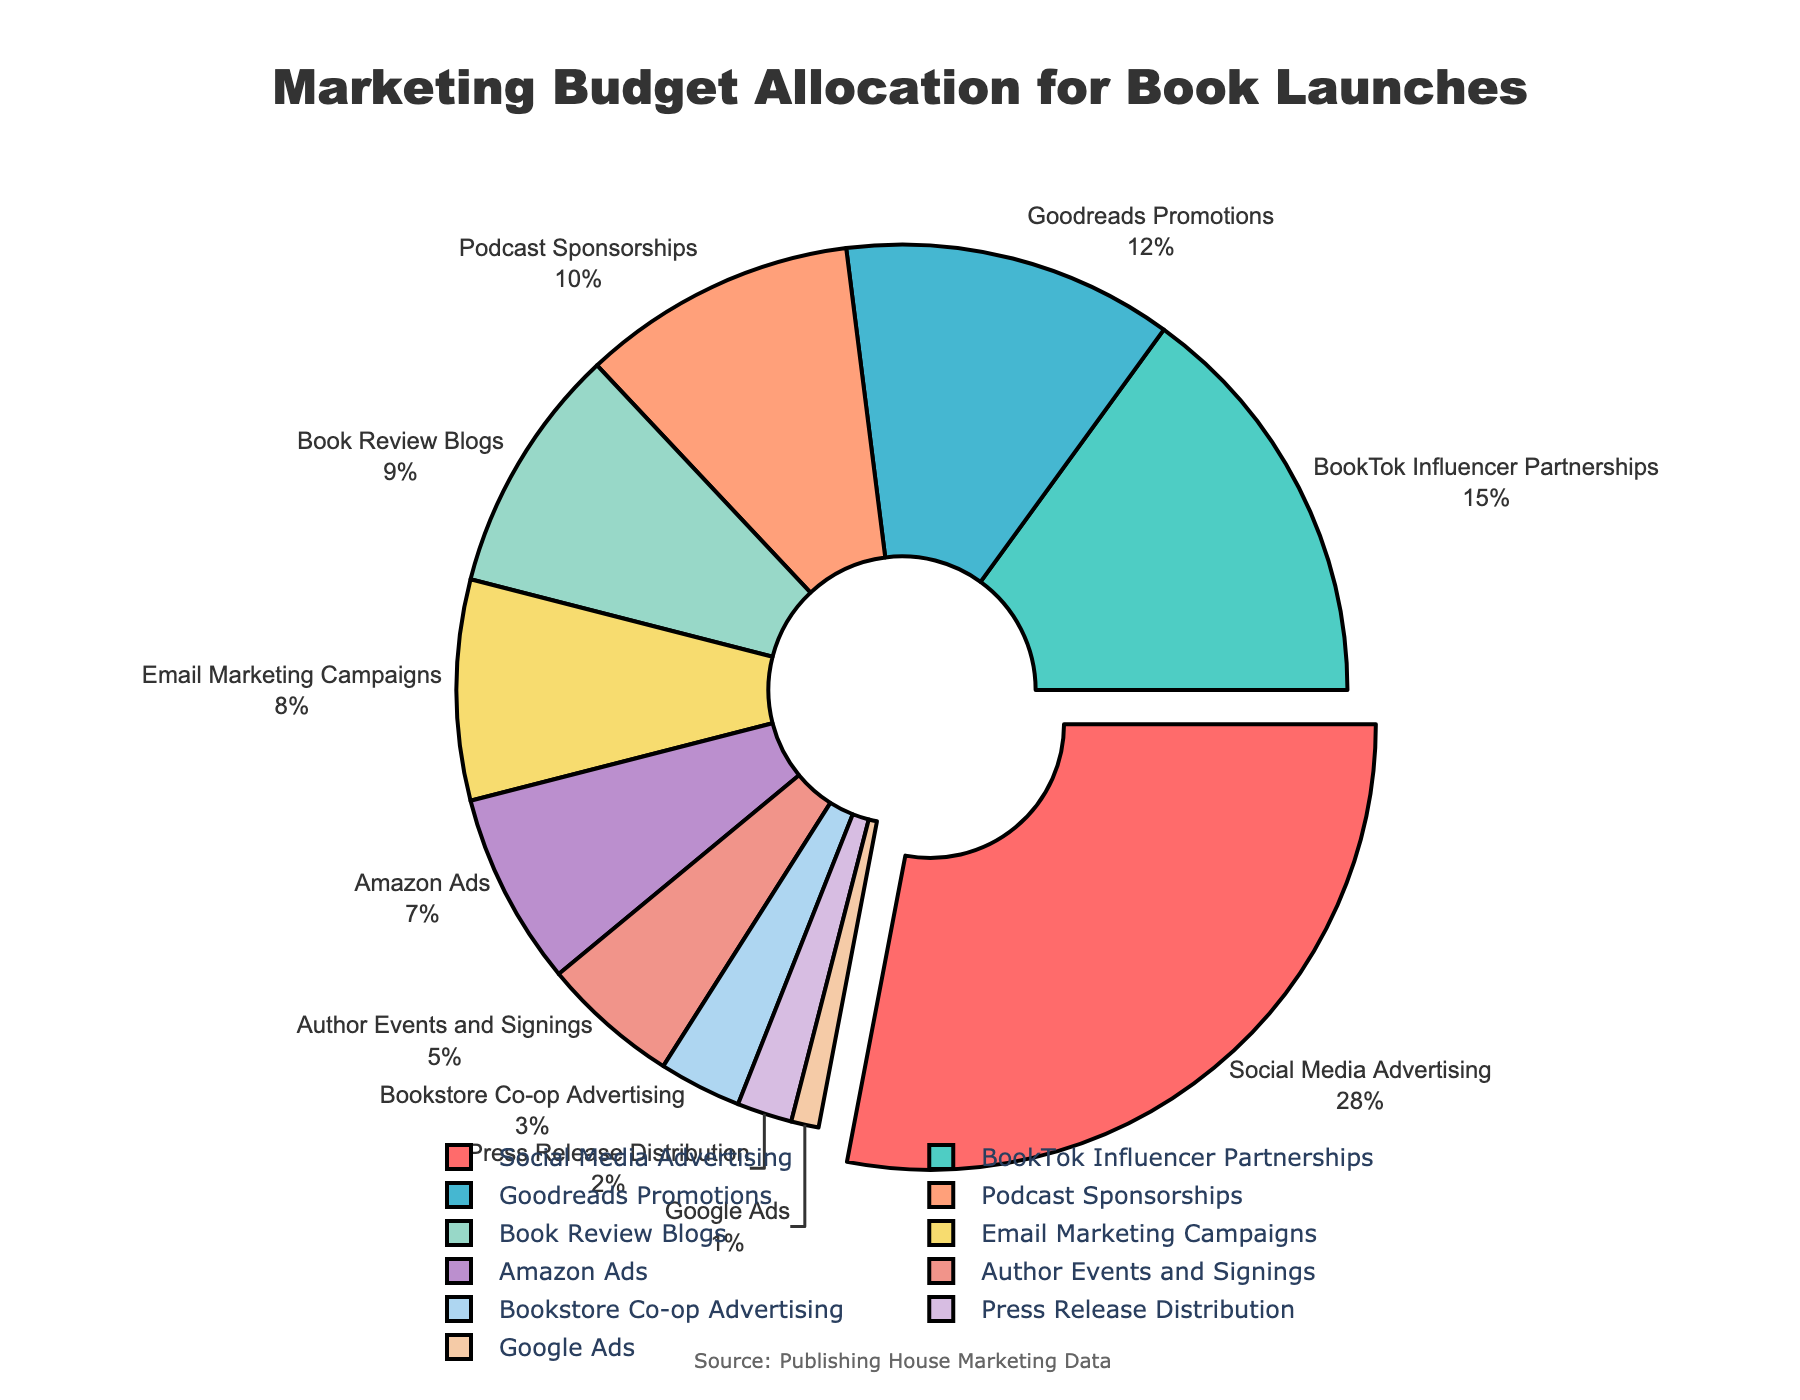What percentage of the marketing budget is allocated to Social Media Advertising? Locate the "Social Media Advertising" segment on the pie chart and read the percentage label next to it.
Answer: 28% Which promotional channel receives the smallest portion of the marketing budget? Identify the segment with the smallest percentage. The smallest segment is labeled "Google Ads" with 1%.
Answer: Google Ads How much more budget is allocated to Social Media Advertising compared to BookTok Influencer Partnerships? Subtract the percentage of BookTok Influencer Partnerships (15%) from Social Media Advertising (28%). 28% - 15% = 13%.
Answer: 13% What is the combined budget allocation for Goodreads Promotions, Podcast Sponsorships, and Book Review Blogs? Sum the percentages of Goodreads Promotions (12%), Podcast Sponsorships (10%), and Book Review Blogs (9%). 12% + 10% + 9% = 31%.
Answer: 31% Which channel receives a larger budget: Email Marketing Campaigns or Amazon Ads? Compare the percentages of Email Marketing Campaigns (8%) and Amazon Ads (7%).
Answer: Email Marketing Campaigns By how many percentage points does Social Media Advertising exceed the combined allocation of Press Release Distribution and Google Ads? Add the percentages for Press Release Distribution (2%) and Google Ads (1%), then subtract the result from Social Media Advertising (28%). 28% - (2% + 1%) = 25%.
Answer: 25% Which color represents Bookstore Co-op Advertising in the pie chart? Identify the segment labeled "Bookstore Co-op Advertising" and note its color.
Answer: Light blue If the total marketing budget is $100,000, how much money is allocated to Podcast Sponsorships? Find the percentage for Podcast Sponsorships (10%) and calculate 10% of $100,000. 0.10 * 100,000 = $10,000.
Answer: $10,000 What is the difference in budget allocation between the channel with the highest and the channel with the lowest allocation? Subtract the smallest percentage (1% for Google Ads) from the largest percentage (28% for Social Media Advertising). 28% - 1% = 27%.
Answer: 27% How many channels receive a budget allocation of 10% or higher? Count the segments labeled with percentages 10% or higher: Social Media Advertising (28%), BookTok Influencer Partnerships (15%), and Goodreads Promotions (12%), Podcast Sponsorships (10%). There are 4 channels.
Answer: 4 